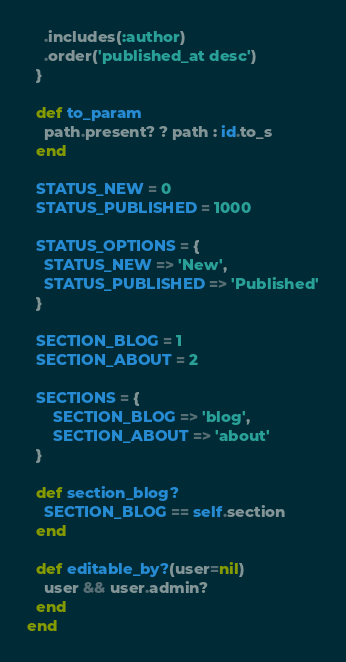<code> <loc_0><loc_0><loc_500><loc_500><_Ruby_>    .includes(:author)
    .order('published_at desc')
  }

  def to_param
    path.present? ? path : id.to_s
  end

  STATUS_NEW = 0
  STATUS_PUBLISHED = 1000

  STATUS_OPTIONS = {
    STATUS_NEW => 'New',
    STATUS_PUBLISHED => 'Published'
  }

  SECTION_BLOG = 1
  SECTION_ABOUT = 2

  SECTIONS = {
      SECTION_BLOG => 'blog',
      SECTION_ABOUT => 'about'
  }

  def section_blog?
    SECTION_BLOG == self.section
  end

  def editable_by?(user=nil)
    user && user.admin?
  end
end
</code> 